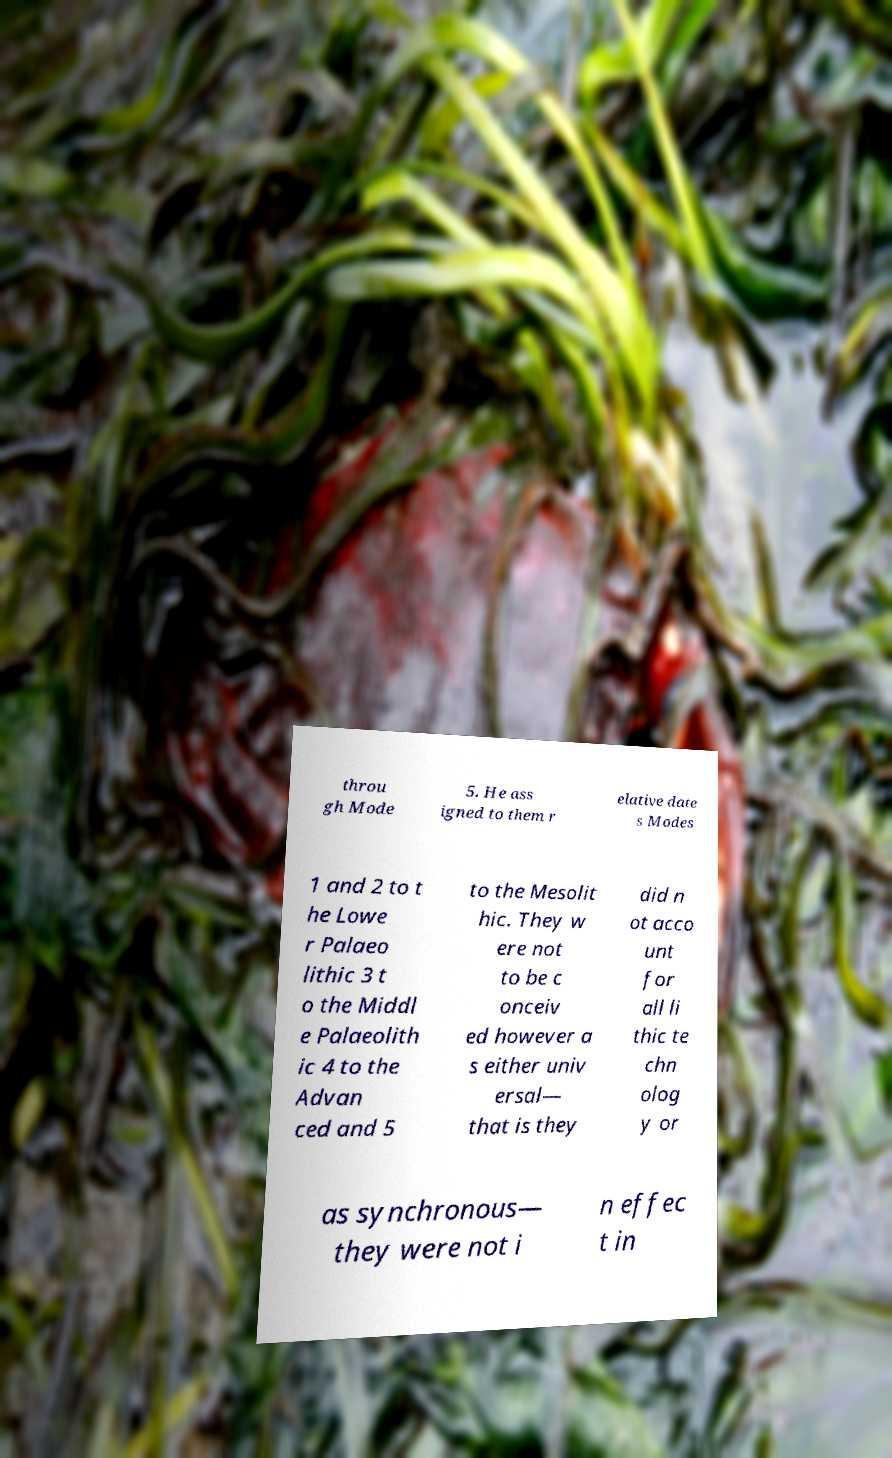Please identify and transcribe the text found in this image. throu gh Mode 5. He ass igned to them r elative date s Modes 1 and 2 to t he Lowe r Palaeo lithic 3 t o the Middl e Palaeolith ic 4 to the Advan ced and 5 to the Mesolit hic. They w ere not to be c onceiv ed however a s either univ ersal— that is they did n ot acco unt for all li thic te chn olog y or as synchronous— they were not i n effec t in 